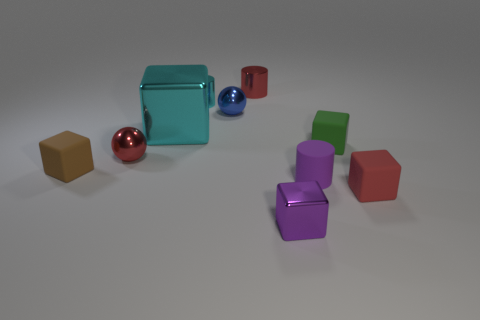Subtract 2 blocks. How many blocks are left? 3 Subtract all red cubes. How many cubes are left? 4 Subtract all purple blocks. How many blocks are left? 4 Subtract all purple blocks. Subtract all purple cylinders. How many blocks are left? 4 Subtract all cylinders. How many objects are left? 7 Subtract 0 gray cylinders. How many objects are left? 10 Subtract all small objects. Subtract all red metallic cylinders. How many objects are left? 0 Add 7 shiny cylinders. How many shiny cylinders are left? 9 Add 3 small red metallic objects. How many small red metallic objects exist? 5 